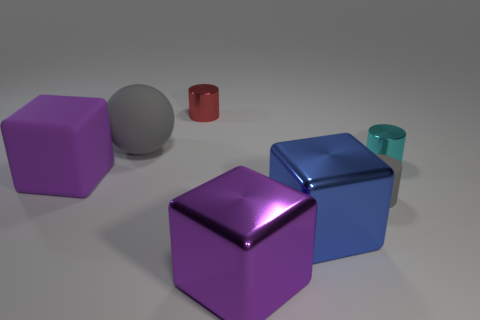Subtract 1 cylinders. How many cylinders are left? 2 Add 2 cylinders. How many objects exist? 9 Subtract all blocks. How many objects are left? 4 Subtract 1 gray spheres. How many objects are left? 6 Subtract all gray matte spheres. Subtract all big blue things. How many objects are left? 5 Add 4 cyan objects. How many cyan objects are left? 5 Add 6 small cyan metallic cylinders. How many small cyan metallic cylinders exist? 7 